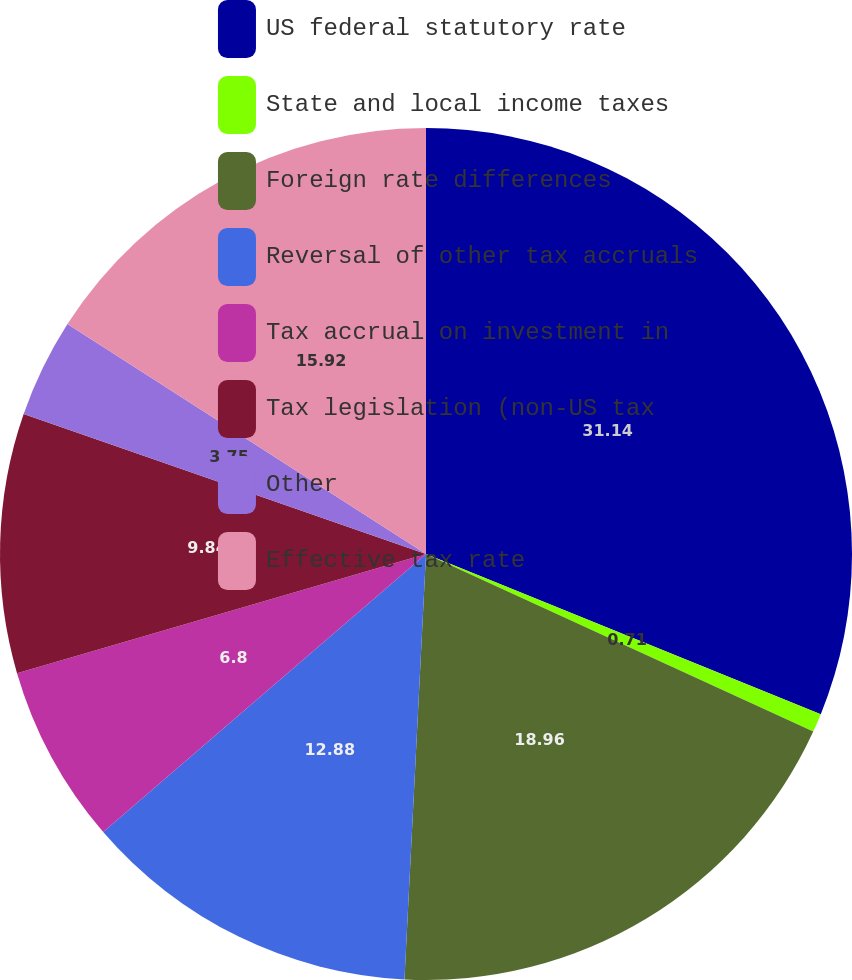<chart> <loc_0><loc_0><loc_500><loc_500><pie_chart><fcel>US federal statutory rate<fcel>State and local income taxes<fcel>Foreign rate differences<fcel>Reversal of other tax accruals<fcel>Tax accrual on investment in<fcel>Tax legislation (non-US tax<fcel>Other<fcel>Effective tax rate<nl><fcel>31.13%<fcel>0.71%<fcel>18.96%<fcel>12.88%<fcel>6.8%<fcel>9.84%<fcel>3.75%<fcel>15.92%<nl></chart> 